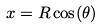Convert formula to latex. <formula><loc_0><loc_0><loc_500><loc_500>x = R \cos ( \theta )</formula> 